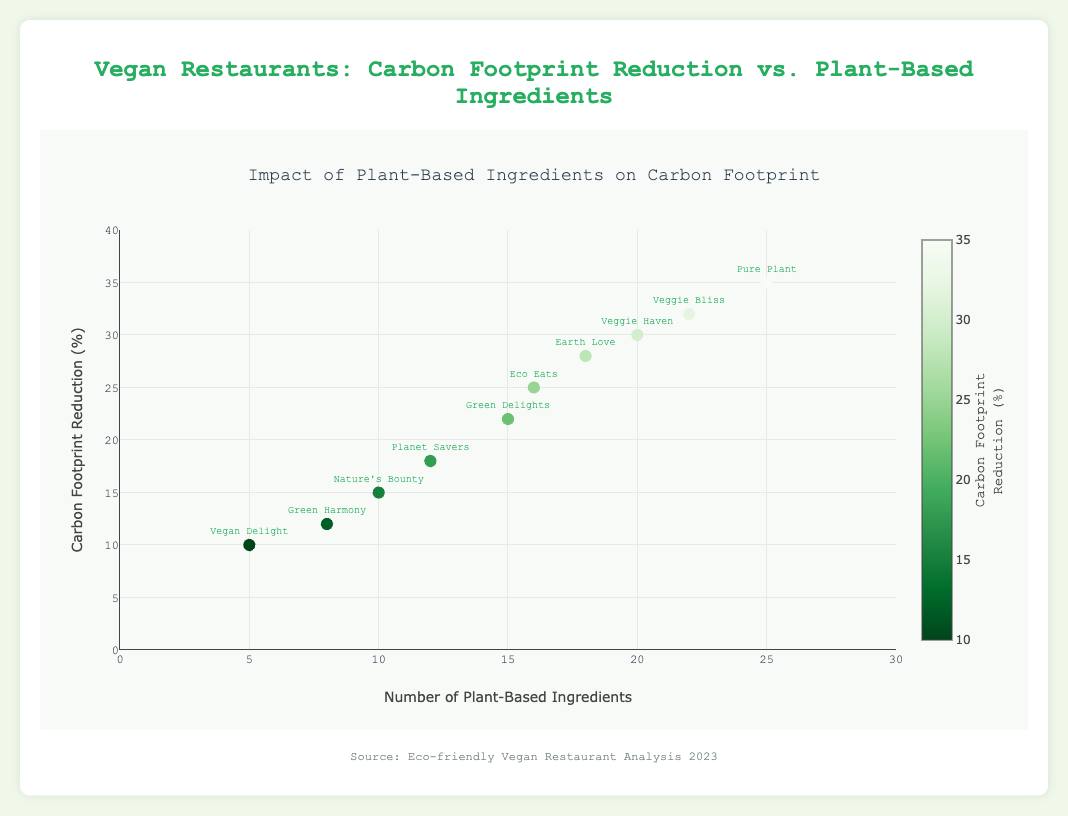What is the title of the figure? The title is located at the top of the figure, and it states the overall theme or topic of the plot.
Answer: Impact of Plant-Based Ingredients on Carbon Footprint How many restaurants are represented in the plot? There are many markers (points) on the plot, each representing a different restaurant. By counting these points, we can determine the number of restaurants.
Answer: 10 Which restaurant has the highest number of plant-based ingredients? Look for the marker with the highest x-value (Plant-Based Ingredients) and identify the corresponding restaurant label.
Answer: Pure Plant What is the carbon footprint reduction percentage for "Green Delights"? Find the marker labeled "Green Delights" and note its y-value (Carbon Footprint Reduction %).
Answer: 22% What is the average number of plant-based ingredients used by the restaurants? Add up the number of plant-based ingredients for all restaurants and divide by the total number of restaurants. (15 + 18 + 20 + 10 + 25 + 8 + 12 + 22 + 16 + 5) / 10 = 151 / 10 = 15.1
Answer: 15.1 Which restaurant has the lowest carbon footprint reduction percentage? Locate the point with the lowest y-value (Carbon Footprint Reduction %) and identify the restaurant label.
Answer: Vegan Delight Between "Eco Eats" and "Planet Savers", which restaurant uses more plant-based ingredients and by how much? Find the x-values for both "Eco Eats" and "Planet Savers", and calculate the difference. 16 (Eco Eats) - 12 (Planet Savers)
Answer: Eco Eats by 4 What color represents the highest carbon footprint reduction percentage, and what is this percentage? Observe the color scale on the plot, find the color associated with the highest value, and determine the corresponding percentage from the colorbar.
Answer: Darkest green, 35% Is there a noticeable trend between the number of plant-based ingredients and carbon footprint reduction percentage? Observe if the markers show a pattern suggesting a relationship between the x (Plant-Based Ingredients) and y (Carbon Footprint Reduction %) coordinates.
Answer: Yes, there is a positive trend 